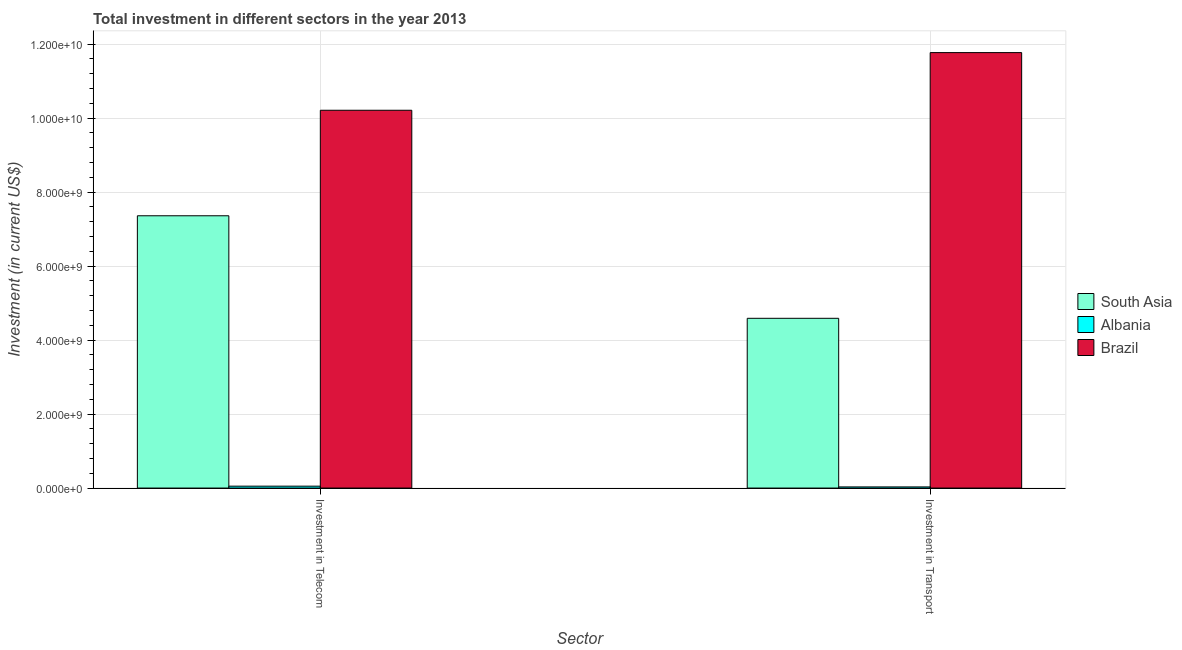How many groups of bars are there?
Your response must be concise. 2. How many bars are there on the 2nd tick from the left?
Make the answer very short. 3. What is the label of the 2nd group of bars from the left?
Provide a short and direct response. Investment in Transport. What is the investment in transport in South Asia?
Offer a terse response. 4.59e+09. Across all countries, what is the maximum investment in telecom?
Offer a terse response. 1.02e+1. Across all countries, what is the minimum investment in transport?
Offer a terse response. 3.05e+07. In which country was the investment in transport minimum?
Offer a very short reply. Albania. What is the total investment in transport in the graph?
Give a very brief answer. 1.64e+1. What is the difference between the investment in telecom in Brazil and that in South Asia?
Ensure brevity in your answer.  2.85e+09. What is the difference between the investment in transport in Albania and the investment in telecom in Brazil?
Your answer should be very brief. -1.02e+1. What is the average investment in transport per country?
Make the answer very short. 5.46e+09. What is the difference between the investment in telecom and investment in transport in South Asia?
Offer a terse response. 2.77e+09. In how many countries, is the investment in telecom greater than 4000000000 US$?
Offer a very short reply. 2. What is the ratio of the investment in telecom in Brazil to that in Albania?
Your answer should be compact. 200.19. What does the 2nd bar from the right in Investment in Transport represents?
Your answer should be compact. Albania. What is the difference between two consecutive major ticks on the Y-axis?
Keep it short and to the point. 2.00e+09. Are the values on the major ticks of Y-axis written in scientific E-notation?
Ensure brevity in your answer.  Yes. How are the legend labels stacked?
Provide a short and direct response. Vertical. What is the title of the graph?
Your answer should be very brief. Total investment in different sectors in the year 2013. Does "Bahamas" appear as one of the legend labels in the graph?
Keep it short and to the point. No. What is the label or title of the X-axis?
Your answer should be very brief. Sector. What is the label or title of the Y-axis?
Your answer should be compact. Investment (in current US$). What is the Investment (in current US$) in South Asia in Investment in Telecom?
Your answer should be very brief. 7.36e+09. What is the Investment (in current US$) in Albania in Investment in Telecom?
Your answer should be very brief. 5.10e+07. What is the Investment (in current US$) in Brazil in Investment in Telecom?
Provide a short and direct response. 1.02e+1. What is the Investment (in current US$) of South Asia in Investment in Transport?
Your answer should be compact. 4.59e+09. What is the Investment (in current US$) in Albania in Investment in Transport?
Offer a very short reply. 3.05e+07. What is the Investment (in current US$) in Brazil in Investment in Transport?
Provide a short and direct response. 1.18e+1. Across all Sector, what is the maximum Investment (in current US$) of South Asia?
Give a very brief answer. 7.36e+09. Across all Sector, what is the maximum Investment (in current US$) of Albania?
Offer a very short reply. 5.10e+07. Across all Sector, what is the maximum Investment (in current US$) of Brazil?
Ensure brevity in your answer.  1.18e+1. Across all Sector, what is the minimum Investment (in current US$) of South Asia?
Provide a short and direct response. 4.59e+09. Across all Sector, what is the minimum Investment (in current US$) of Albania?
Ensure brevity in your answer.  3.05e+07. Across all Sector, what is the minimum Investment (in current US$) of Brazil?
Your answer should be very brief. 1.02e+1. What is the total Investment (in current US$) in South Asia in the graph?
Provide a short and direct response. 1.19e+1. What is the total Investment (in current US$) in Albania in the graph?
Offer a very short reply. 8.15e+07. What is the total Investment (in current US$) in Brazil in the graph?
Your answer should be very brief. 2.20e+1. What is the difference between the Investment (in current US$) of South Asia in Investment in Telecom and that in Investment in Transport?
Provide a short and direct response. 2.77e+09. What is the difference between the Investment (in current US$) in Albania in Investment in Telecom and that in Investment in Transport?
Your answer should be compact. 2.05e+07. What is the difference between the Investment (in current US$) in Brazil in Investment in Telecom and that in Investment in Transport?
Give a very brief answer. -1.56e+09. What is the difference between the Investment (in current US$) of South Asia in Investment in Telecom and the Investment (in current US$) of Albania in Investment in Transport?
Keep it short and to the point. 7.33e+09. What is the difference between the Investment (in current US$) in South Asia in Investment in Telecom and the Investment (in current US$) in Brazil in Investment in Transport?
Your answer should be very brief. -4.41e+09. What is the difference between the Investment (in current US$) in Albania in Investment in Telecom and the Investment (in current US$) in Brazil in Investment in Transport?
Offer a terse response. -1.17e+1. What is the average Investment (in current US$) in South Asia per Sector?
Give a very brief answer. 5.97e+09. What is the average Investment (in current US$) of Albania per Sector?
Ensure brevity in your answer.  4.08e+07. What is the average Investment (in current US$) of Brazil per Sector?
Your response must be concise. 1.10e+1. What is the difference between the Investment (in current US$) in South Asia and Investment (in current US$) in Albania in Investment in Telecom?
Your answer should be very brief. 7.31e+09. What is the difference between the Investment (in current US$) of South Asia and Investment (in current US$) of Brazil in Investment in Telecom?
Ensure brevity in your answer.  -2.85e+09. What is the difference between the Investment (in current US$) of Albania and Investment (in current US$) of Brazil in Investment in Telecom?
Offer a terse response. -1.02e+1. What is the difference between the Investment (in current US$) of South Asia and Investment (in current US$) of Albania in Investment in Transport?
Provide a short and direct response. 4.56e+09. What is the difference between the Investment (in current US$) of South Asia and Investment (in current US$) of Brazil in Investment in Transport?
Offer a very short reply. -7.18e+09. What is the difference between the Investment (in current US$) of Albania and Investment (in current US$) of Brazil in Investment in Transport?
Provide a short and direct response. -1.17e+1. What is the ratio of the Investment (in current US$) in South Asia in Investment in Telecom to that in Investment in Transport?
Provide a short and direct response. 1.6. What is the ratio of the Investment (in current US$) of Albania in Investment in Telecom to that in Investment in Transport?
Keep it short and to the point. 1.67. What is the ratio of the Investment (in current US$) in Brazil in Investment in Telecom to that in Investment in Transport?
Your answer should be very brief. 0.87. What is the difference between the highest and the second highest Investment (in current US$) in South Asia?
Your answer should be compact. 2.77e+09. What is the difference between the highest and the second highest Investment (in current US$) in Albania?
Your response must be concise. 2.05e+07. What is the difference between the highest and the second highest Investment (in current US$) in Brazil?
Make the answer very short. 1.56e+09. What is the difference between the highest and the lowest Investment (in current US$) of South Asia?
Your answer should be very brief. 2.77e+09. What is the difference between the highest and the lowest Investment (in current US$) of Albania?
Give a very brief answer. 2.05e+07. What is the difference between the highest and the lowest Investment (in current US$) in Brazil?
Ensure brevity in your answer.  1.56e+09. 